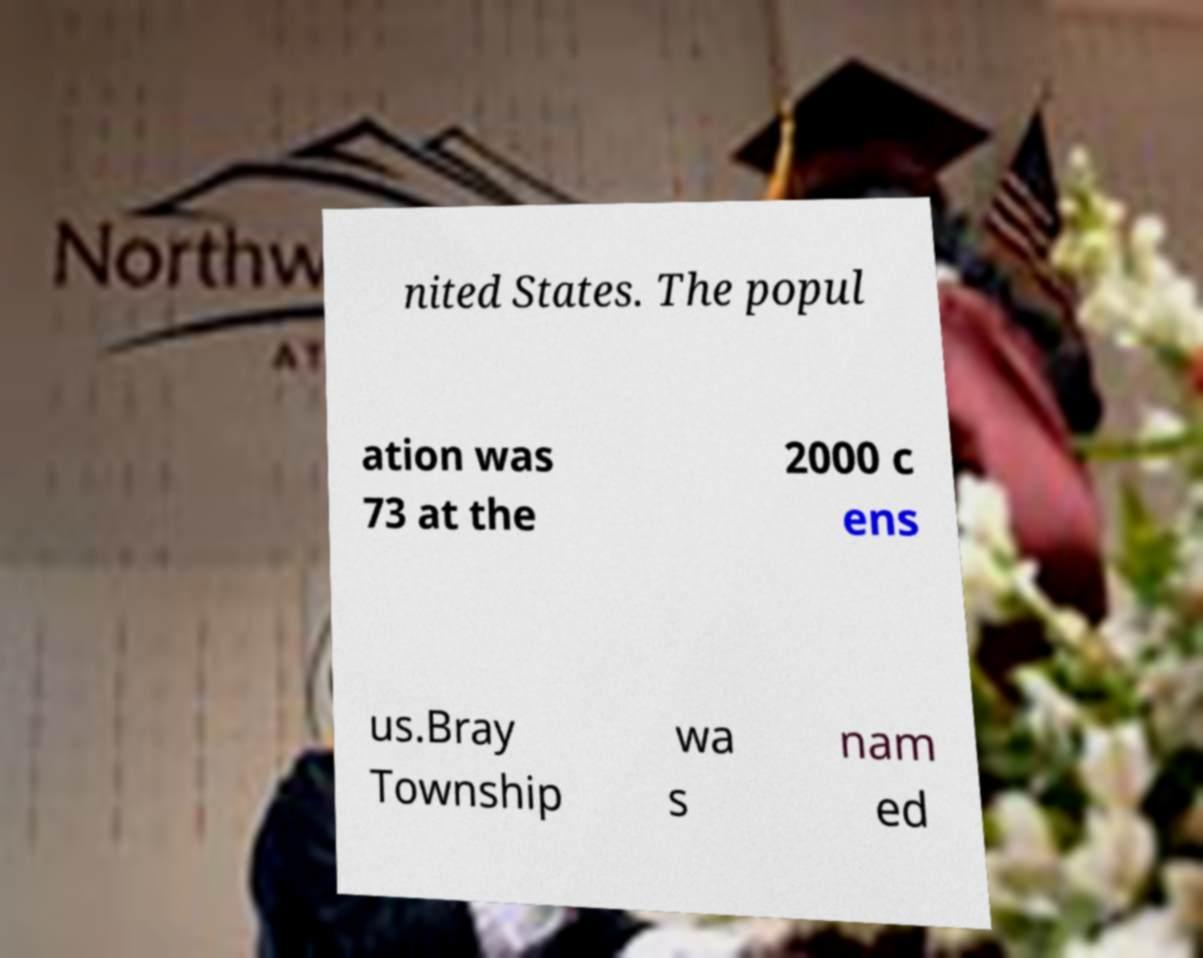What messages or text are displayed in this image? I need them in a readable, typed format. nited States. The popul ation was 73 at the 2000 c ens us.Bray Township wa s nam ed 